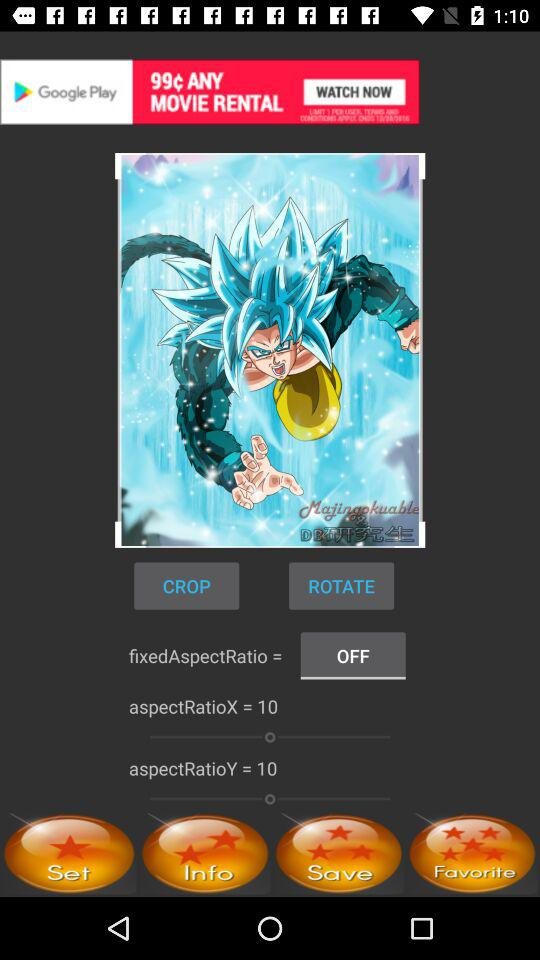What is the aspectRatioX? The aspectRatioX is 10. 